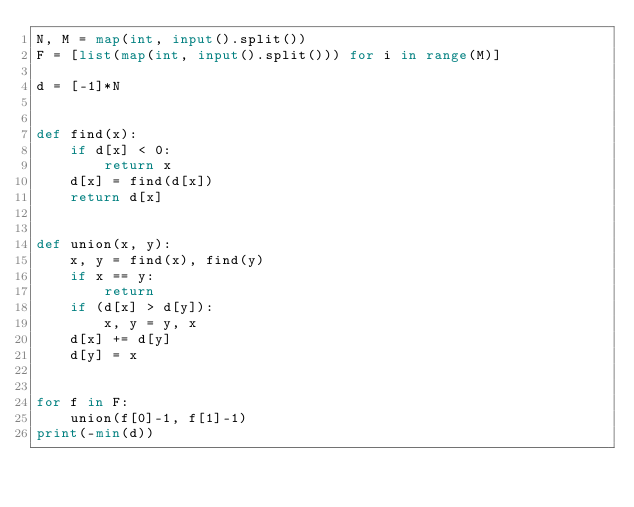Convert code to text. <code><loc_0><loc_0><loc_500><loc_500><_Python_>N, M = map(int, input().split())
F = [list(map(int, input().split())) for i in range(M)]

d = [-1]*N


def find(x):
    if d[x] < 0:
        return x
    d[x] = find(d[x])
    return d[x]


def union(x, y):
    x, y = find(x), find(y)
    if x == y:
        return
    if (d[x] > d[y]):
        x, y = y, x
    d[x] += d[y]
    d[y] = x


for f in F:
    union(f[0]-1, f[1]-1)
print(-min(d))
</code> 